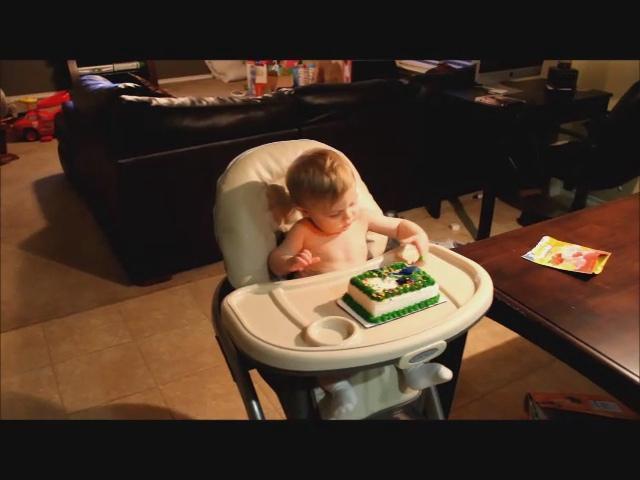How many couches are there?
Give a very brief answer. 2. How many chairs can you see?
Give a very brief answer. 2. How many green-topped spray bottles are there?
Give a very brief answer. 0. 